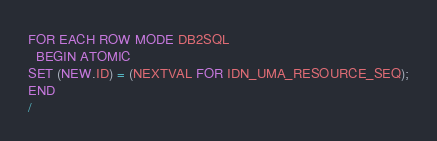<code> <loc_0><loc_0><loc_500><loc_500><_SQL_>FOR EACH ROW MODE DB2SQL
  BEGIN ATOMIC
SET (NEW.ID) = (NEXTVAL FOR IDN_UMA_RESOURCE_SEQ);
END
/
</code> 